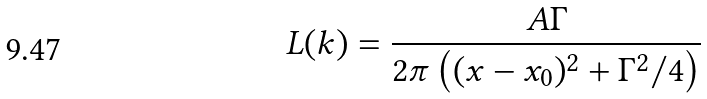<formula> <loc_0><loc_0><loc_500><loc_500>L ( k ) = \frac { A \Gamma } { 2 \pi \left ( ( x - x _ { 0 } ) ^ { 2 } + \Gamma ^ { 2 } / 4 \right ) }</formula> 